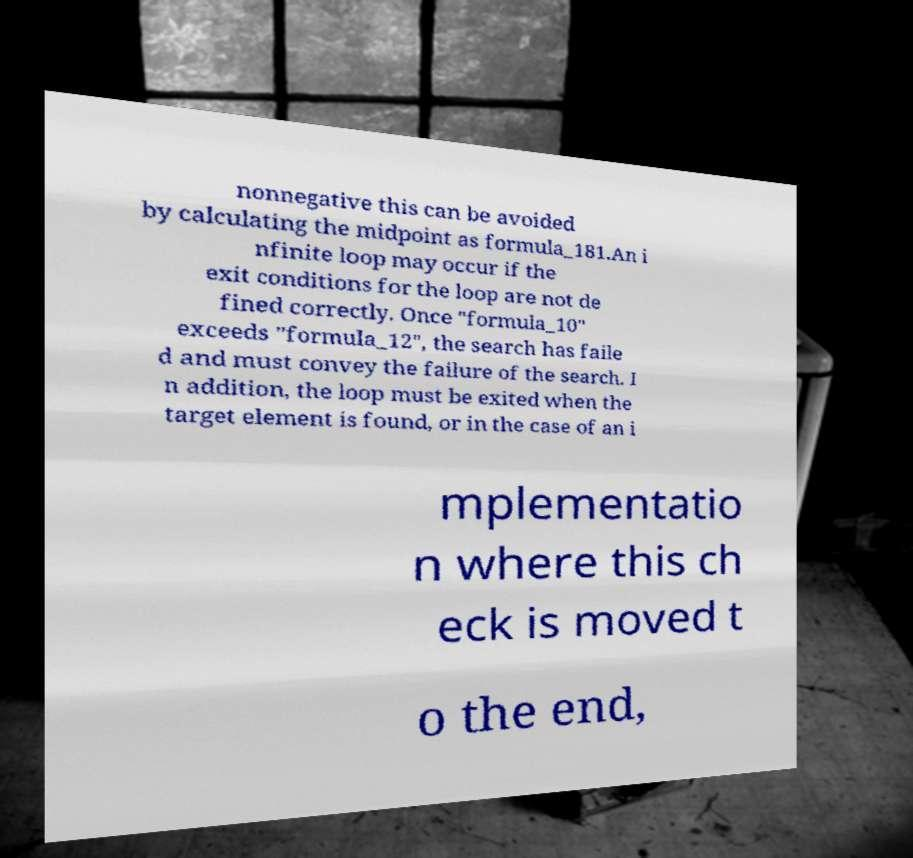What messages or text are displayed in this image? I need them in a readable, typed format. nonnegative this can be avoided by calculating the midpoint as formula_181.An i nfinite loop may occur if the exit conditions for the loop are not de fined correctly. Once "formula_10" exceeds "formula_12", the search has faile d and must convey the failure of the search. I n addition, the loop must be exited when the target element is found, or in the case of an i mplementatio n where this ch eck is moved t o the end, 